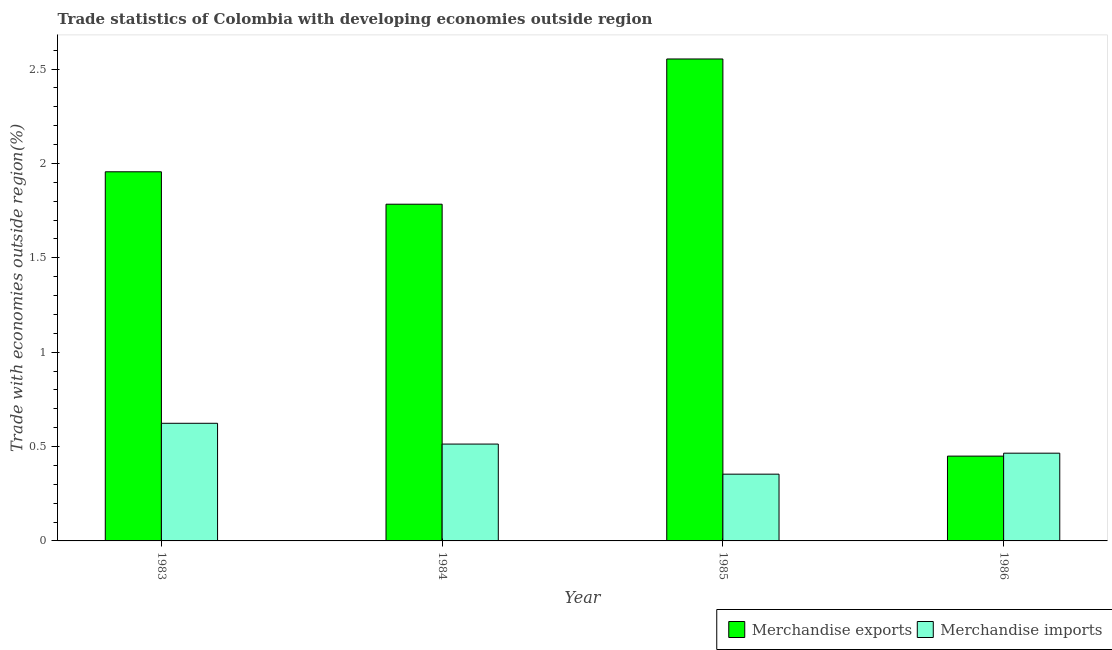How many groups of bars are there?
Offer a terse response. 4. Are the number of bars per tick equal to the number of legend labels?
Offer a terse response. Yes. How many bars are there on the 1st tick from the left?
Give a very brief answer. 2. What is the label of the 1st group of bars from the left?
Your response must be concise. 1983. In how many cases, is the number of bars for a given year not equal to the number of legend labels?
Offer a very short reply. 0. What is the merchandise imports in 1985?
Your response must be concise. 0.35. Across all years, what is the maximum merchandise imports?
Provide a short and direct response. 0.62. Across all years, what is the minimum merchandise exports?
Keep it short and to the point. 0.45. What is the total merchandise imports in the graph?
Offer a very short reply. 1.95. What is the difference between the merchandise imports in 1984 and that in 1985?
Your answer should be very brief. 0.16. What is the difference between the merchandise exports in 1986 and the merchandise imports in 1985?
Your response must be concise. -2.1. What is the average merchandise imports per year?
Offer a terse response. 0.49. In how many years, is the merchandise exports greater than 1.1 %?
Your answer should be compact. 3. What is the ratio of the merchandise exports in 1984 to that in 1986?
Make the answer very short. 3.97. Is the difference between the merchandise imports in 1983 and 1986 greater than the difference between the merchandise exports in 1983 and 1986?
Offer a very short reply. No. What is the difference between the highest and the second highest merchandise imports?
Ensure brevity in your answer.  0.11. What is the difference between the highest and the lowest merchandise exports?
Give a very brief answer. 2.1. Is the sum of the merchandise exports in 1983 and 1985 greater than the maximum merchandise imports across all years?
Provide a short and direct response. Yes. What does the 2nd bar from the left in 1983 represents?
Your response must be concise. Merchandise imports. What does the 1st bar from the right in 1985 represents?
Provide a succinct answer. Merchandise imports. Are all the bars in the graph horizontal?
Provide a succinct answer. No. What is the difference between two consecutive major ticks on the Y-axis?
Provide a short and direct response. 0.5. Does the graph contain grids?
Your answer should be compact. No. Where does the legend appear in the graph?
Your answer should be compact. Bottom right. How are the legend labels stacked?
Make the answer very short. Horizontal. What is the title of the graph?
Offer a terse response. Trade statistics of Colombia with developing economies outside region. Does "Age 65(female)" appear as one of the legend labels in the graph?
Keep it short and to the point. No. What is the label or title of the X-axis?
Give a very brief answer. Year. What is the label or title of the Y-axis?
Make the answer very short. Trade with economies outside region(%). What is the Trade with economies outside region(%) in Merchandise exports in 1983?
Provide a succinct answer. 1.96. What is the Trade with economies outside region(%) in Merchandise imports in 1983?
Keep it short and to the point. 0.62. What is the Trade with economies outside region(%) of Merchandise exports in 1984?
Provide a succinct answer. 1.78. What is the Trade with economies outside region(%) in Merchandise imports in 1984?
Provide a short and direct response. 0.51. What is the Trade with economies outside region(%) of Merchandise exports in 1985?
Make the answer very short. 2.55. What is the Trade with economies outside region(%) of Merchandise imports in 1985?
Give a very brief answer. 0.35. What is the Trade with economies outside region(%) of Merchandise exports in 1986?
Ensure brevity in your answer.  0.45. What is the Trade with economies outside region(%) of Merchandise imports in 1986?
Ensure brevity in your answer.  0.46. Across all years, what is the maximum Trade with economies outside region(%) in Merchandise exports?
Provide a short and direct response. 2.55. Across all years, what is the maximum Trade with economies outside region(%) in Merchandise imports?
Provide a succinct answer. 0.62. Across all years, what is the minimum Trade with economies outside region(%) of Merchandise exports?
Ensure brevity in your answer.  0.45. Across all years, what is the minimum Trade with economies outside region(%) in Merchandise imports?
Give a very brief answer. 0.35. What is the total Trade with economies outside region(%) in Merchandise exports in the graph?
Offer a terse response. 6.74. What is the total Trade with economies outside region(%) of Merchandise imports in the graph?
Offer a terse response. 1.95. What is the difference between the Trade with economies outside region(%) of Merchandise exports in 1983 and that in 1984?
Your response must be concise. 0.17. What is the difference between the Trade with economies outside region(%) of Merchandise imports in 1983 and that in 1984?
Provide a succinct answer. 0.11. What is the difference between the Trade with economies outside region(%) in Merchandise exports in 1983 and that in 1985?
Offer a terse response. -0.6. What is the difference between the Trade with economies outside region(%) in Merchandise imports in 1983 and that in 1985?
Your answer should be very brief. 0.27. What is the difference between the Trade with economies outside region(%) in Merchandise exports in 1983 and that in 1986?
Provide a succinct answer. 1.51. What is the difference between the Trade with economies outside region(%) of Merchandise imports in 1983 and that in 1986?
Your response must be concise. 0.16. What is the difference between the Trade with economies outside region(%) of Merchandise exports in 1984 and that in 1985?
Your response must be concise. -0.77. What is the difference between the Trade with economies outside region(%) in Merchandise imports in 1984 and that in 1985?
Provide a short and direct response. 0.16. What is the difference between the Trade with economies outside region(%) in Merchandise exports in 1984 and that in 1986?
Offer a very short reply. 1.33. What is the difference between the Trade with economies outside region(%) of Merchandise imports in 1984 and that in 1986?
Make the answer very short. 0.05. What is the difference between the Trade with economies outside region(%) in Merchandise exports in 1985 and that in 1986?
Offer a terse response. 2.1. What is the difference between the Trade with economies outside region(%) of Merchandise imports in 1985 and that in 1986?
Your answer should be compact. -0.11. What is the difference between the Trade with economies outside region(%) in Merchandise exports in 1983 and the Trade with economies outside region(%) in Merchandise imports in 1984?
Make the answer very short. 1.44. What is the difference between the Trade with economies outside region(%) in Merchandise exports in 1983 and the Trade with economies outside region(%) in Merchandise imports in 1985?
Keep it short and to the point. 1.6. What is the difference between the Trade with economies outside region(%) of Merchandise exports in 1983 and the Trade with economies outside region(%) of Merchandise imports in 1986?
Your response must be concise. 1.49. What is the difference between the Trade with economies outside region(%) of Merchandise exports in 1984 and the Trade with economies outside region(%) of Merchandise imports in 1985?
Provide a short and direct response. 1.43. What is the difference between the Trade with economies outside region(%) in Merchandise exports in 1984 and the Trade with economies outside region(%) in Merchandise imports in 1986?
Provide a short and direct response. 1.32. What is the difference between the Trade with economies outside region(%) of Merchandise exports in 1985 and the Trade with economies outside region(%) of Merchandise imports in 1986?
Give a very brief answer. 2.09. What is the average Trade with economies outside region(%) of Merchandise exports per year?
Your answer should be very brief. 1.69. What is the average Trade with economies outside region(%) of Merchandise imports per year?
Your response must be concise. 0.49. In the year 1983, what is the difference between the Trade with economies outside region(%) of Merchandise exports and Trade with economies outside region(%) of Merchandise imports?
Provide a succinct answer. 1.33. In the year 1984, what is the difference between the Trade with economies outside region(%) in Merchandise exports and Trade with economies outside region(%) in Merchandise imports?
Your answer should be compact. 1.27. In the year 1985, what is the difference between the Trade with economies outside region(%) in Merchandise exports and Trade with economies outside region(%) in Merchandise imports?
Provide a succinct answer. 2.2. In the year 1986, what is the difference between the Trade with economies outside region(%) of Merchandise exports and Trade with economies outside region(%) of Merchandise imports?
Your answer should be very brief. -0.02. What is the ratio of the Trade with economies outside region(%) of Merchandise exports in 1983 to that in 1984?
Your answer should be compact. 1.1. What is the ratio of the Trade with economies outside region(%) of Merchandise imports in 1983 to that in 1984?
Your response must be concise. 1.21. What is the ratio of the Trade with economies outside region(%) of Merchandise exports in 1983 to that in 1985?
Ensure brevity in your answer.  0.77. What is the ratio of the Trade with economies outside region(%) of Merchandise imports in 1983 to that in 1985?
Your response must be concise. 1.76. What is the ratio of the Trade with economies outside region(%) of Merchandise exports in 1983 to that in 1986?
Offer a very short reply. 4.35. What is the ratio of the Trade with economies outside region(%) in Merchandise imports in 1983 to that in 1986?
Your response must be concise. 1.34. What is the ratio of the Trade with economies outside region(%) in Merchandise exports in 1984 to that in 1985?
Offer a terse response. 0.7. What is the ratio of the Trade with economies outside region(%) in Merchandise imports in 1984 to that in 1985?
Your answer should be compact. 1.45. What is the ratio of the Trade with economies outside region(%) in Merchandise exports in 1984 to that in 1986?
Ensure brevity in your answer.  3.97. What is the ratio of the Trade with economies outside region(%) of Merchandise imports in 1984 to that in 1986?
Provide a short and direct response. 1.1. What is the ratio of the Trade with economies outside region(%) of Merchandise exports in 1985 to that in 1986?
Your answer should be compact. 5.68. What is the ratio of the Trade with economies outside region(%) in Merchandise imports in 1985 to that in 1986?
Provide a short and direct response. 0.76. What is the difference between the highest and the second highest Trade with economies outside region(%) in Merchandise exports?
Make the answer very short. 0.6. What is the difference between the highest and the second highest Trade with economies outside region(%) of Merchandise imports?
Provide a short and direct response. 0.11. What is the difference between the highest and the lowest Trade with economies outside region(%) in Merchandise exports?
Give a very brief answer. 2.1. What is the difference between the highest and the lowest Trade with economies outside region(%) of Merchandise imports?
Make the answer very short. 0.27. 